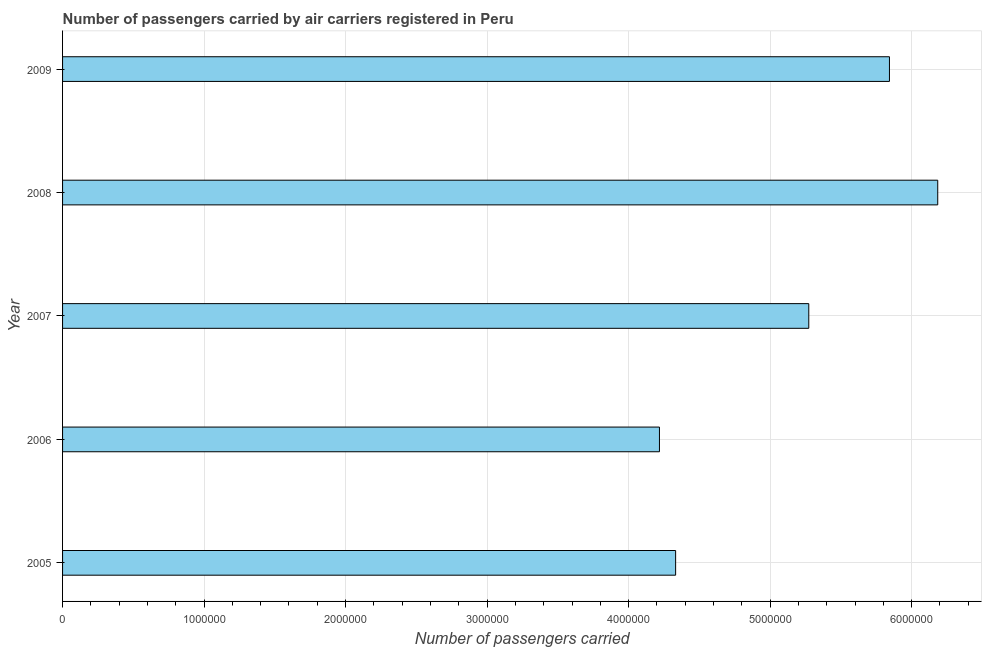Does the graph contain grids?
Provide a short and direct response. Yes. What is the title of the graph?
Your answer should be compact. Number of passengers carried by air carriers registered in Peru. What is the label or title of the X-axis?
Make the answer very short. Number of passengers carried. What is the label or title of the Y-axis?
Provide a short and direct response. Year. What is the number of passengers carried in 2009?
Your response must be concise. 5.84e+06. Across all years, what is the maximum number of passengers carried?
Offer a terse response. 6.18e+06. Across all years, what is the minimum number of passengers carried?
Offer a very short reply. 4.22e+06. In which year was the number of passengers carried maximum?
Make the answer very short. 2008. What is the sum of the number of passengers carried?
Your response must be concise. 2.59e+07. What is the difference between the number of passengers carried in 2005 and 2007?
Provide a succinct answer. -9.41e+05. What is the average number of passengers carried per year?
Offer a very short reply. 5.17e+06. What is the median number of passengers carried?
Provide a short and direct response. 5.27e+06. What is the ratio of the number of passengers carried in 2008 to that in 2009?
Ensure brevity in your answer.  1.06. What is the difference between the highest and the second highest number of passengers carried?
Your answer should be compact. 3.41e+05. Is the sum of the number of passengers carried in 2005 and 2009 greater than the maximum number of passengers carried across all years?
Provide a short and direct response. Yes. What is the difference between the highest and the lowest number of passengers carried?
Ensure brevity in your answer.  1.97e+06. What is the Number of passengers carried in 2005?
Keep it short and to the point. 4.33e+06. What is the Number of passengers carried in 2006?
Provide a succinct answer. 4.22e+06. What is the Number of passengers carried in 2007?
Ensure brevity in your answer.  5.27e+06. What is the Number of passengers carried in 2008?
Offer a terse response. 6.18e+06. What is the Number of passengers carried of 2009?
Make the answer very short. 5.84e+06. What is the difference between the Number of passengers carried in 2005 and 2006?
Keep it short and to the point. 1.14e+05. What is the difference between the Number of passengers carried in 2005 and 2007?
Make the answer very short. -9.41e+05. What is the difference between the Number of passengers carried in 2005 and 2008?
Make the answer very short. -1.85e+06. What is the difference between the Number of passengers carried in 2005 and 2009?
Give a very brief answer. -1.51e+06. What is the difference between the Number of passengers carried in 2006 and 2007?
Your answer should be very brief. -1.06e+06. What is the difference between the Number of passengers carried in 2006 and 2008?
Your response must be concise. -1.97e+06. What is the difference between the Number of passengers carried in 2006 and 2009?
Your answer should be compact. -1.63e+06. What is the difference between the Number of passengers carried in 2007 and 2008?
Keep it short and to the point. -9.11e+05. What is the difference between the Number of passengers carried in 2007 and 2009?
Offer a very short reply. -5.70e+05. What is the difference between the Number of passengers carried in 2008 and 2009?
Offer a very short reply. 3.41e+05. What is the ratio of the Number of passengers carried in 2005 to that in 2007?
Keep it short and to the point. 0.82. What is the ratio of the Number of passengers carried in 2005 to that in 2008?
Your response must be concise. 0.7. What is the ratio of the Number of passengers carried in 2005 to that in 2009?
Offer a very short reply. 0.74. What is the ratio of the Number of passengers carried in 2006 to that in 2008?
Provide a succinct answer. 0.68. What is the ratio of the Number of passengers carried in 2006 to that in 2009?
Offer a very short reply. 0.72. What is the ratio of the Number of passengers carried in 2007 to that in 2008?
Provide a short and direct response. 0.85. What is the ratio of the Number of passengers carried in 2007 to that in 2009?
Provide a succinct answer. 0.9. What is the ratio of the Number of passengers carried in 2008 to that in 2009?
Your response must be concise. 1.06. 